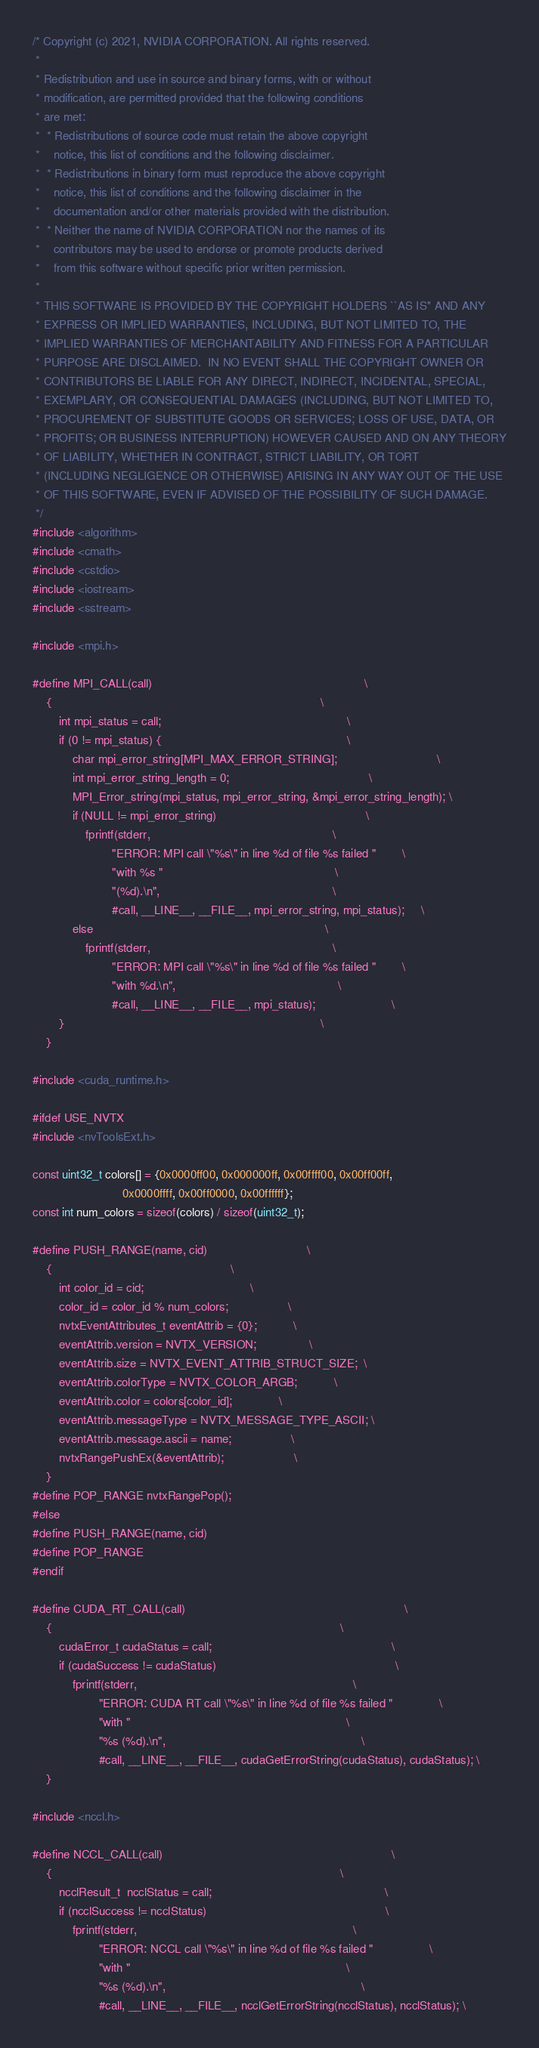Convert code to text. <code><loc_0><loc_0><loc_500><loc_500><_C++_>/* Copyright (c) 2021, NVIDIA CORPORATION. All rights reserved.
 *
 * Redistribution and use in source and binary forms, with or without
 * modification, are permitted provided that the following conditions
 * are met:
 *  * Redistributions of source code must retain the above copyright
 *    notice, this list of conditions and the following disclaimer.
 *  * Redistributions in binary form must reproduce the above copyright
 *    notice, this list of conditions and the following disclaimer in the
 *    documentation and/or other materials provided with the distribution.
 *  * Neither the name of NVIDIA CORPORATION nor the names of its
 *    contributors may be used to endorse or promote products derived
 *    from this software without specific prior written permission.
 *
 * THIS SOFTWARE IS PROVIDED BY THE COPYRIGHT HOLDERS ``AS IS'' AND ANY
 * EXPRESS OR IMPLIED WARRANTIES, INCLUDING, BUT NOT LIMITED TO, THE
 * IMPLIED WARRANTIES OF MERCHANTABILITY AND FITNESS FOR A PARTICULAR
 * PURPOSE ARE DISCLAIMED.  IN NO EVENT SHALL THE COPYRIGHT OWNER OR
 * CONTRIBUTORS BE LIABLE FOR ANY DIRECT, INDIRECT, INCIDENTAL, SPECIAL,
 * EXEMPLARY, OR CONSEQUENTIAL DAMAGES (INCLUDING, BUT NOT LIMITED TO,
 * PROCUREMENT OF SUBSTITUTE GOODS OR SERVICES; LOSS OF USE, DATA, OR
 * PROFITS; OR BUSINESS INTERRUPTION) HOWEVER CAUSED AND ON ANY THEORY
 * OF LIABILITY, WHETHER IN CONTRACT, STRICT LIABILITY, OR TORT
 * (INCLUDING NEGLIGENCE OR OTHERWISE) ARISING IN ANY WAY OUT OF THE USE
 * OF THIS SOFTWARE, EVEN IF ADVISED OF THE POSSIBILITY OF SUCH DAMAGE.
 */
#include <algorithm>
#include <cmath>
#include <cstdio>
#include <iostream>
#include <sstream>

#include <mpi.h>

#define MPI_CALL(call)                                                                \
    {                                                                                 \
        int mpi_status = call;                                                        \
        if (0 != mpi_status) {                                                        \
            char mpi_error_string[MPI_MAX_ERROR_STRING];                              \
            int mpi_error_string_length = 0;                                          \
            MPI_Error_string(mpi_status, mpi_error_string, &mpi_error_string_length); \
            if (NULL != mpi_error_string)                                             \
                fprintf(stderr,                                                       \
                        "ERROR: MPI call \"%s\" in line %d of file %s failed "        \
                        "with %s "                                                    \
                        "(%d).\n",                                                    \
                        #call, __LINE__, __FILE__, mpi_error_string, mpi_status);     \
            else                                                                      \
                fprintf(stderr,                                                       \
                        "ERROR: MPI call \"%s\" in line %d of file %s failed "        \
                        "with %d.\n",                                                 \
                        #call, __LINE__, __FILE__, mpi_status);                       \
        }                                                                             \
    }

#include <cuda_runtime.h>

#ifdef USE_NVTX
#include <nvToolsExt.h>

const uint32_t colors[] = {0x0000ff00, 0x000000ff, 0x00ffff00, 0x00ff00ff,
                           0x0000ffff, 0x00ff0000, 0x00ffffff};
const int num_colors = sizeof(colors) / sizeof(uint32_t);

#define PUSH_RANGE(name, cid)                              \
    {                                                      \
        int color_id = cid;                                \
        color_id = color_id % num_colors;                  \
        nvtxEventAttributes_t eventAttrib = {0};           \
        eventAttrib.version = NVTX_VERSION;                \
        eventAttrib.size = NVTX_EVENT_ATTRIB_STRUCT_SIZE;  \
        eventAttrib.colorType = NVTX_COLOR_ARGB;           \
        eventAttrib.color = colors[color_id];              \
        eventAttrib.messageType = NVTX_MESSAGE_TYPE_ASCII; \
        eventAttrib.message.ascii = name;                  \
        nvtxRangePushEx(&eventAttrib);                     \
    }
#define POP_RANGE nvtxRangePop();
#else
#define PUSH_RANGE(name, cid)
#define POP_RANGE
#endif

#define CUDA_RT_CALL(call)                                                                  \
    {                                                                                       \
        cudaError_t cudaStatus = call;                                                      \
        if (cudaSuccess != cudaStatus)                                                      \
            fprintf(stderr,                                                                 \
                    "ERROR: CUDA RT call \"%s\" in line %d of file %s failed "              \
                    "with "                                                                 \
                    "%s (%d).\n",                                                           \
                    #call, __LINE__, __FILE__, cudaGetErrorString(cudaStatus), cudaStatus); \
    }

#include <nccl.h>

#define NCCL_CALL(call)                                                                     \
    {                                                                                       \
        ncclResult_t  ncclStatus = call;                                                    \
        if (ncclSuccess != ncclStatus)                                                      \
            fprintf(stderr,                                                                 \
                    "ERROR: NCCL call \"%s\" in line %d of file %s failed "                 \
                    "with "                                                                 \
                    "%s (%d).\n",                                                           \
                    #call, __LINE__, __FILE__, ncclGetErrorString(ncclStatus), ncclStatus); \</code> 